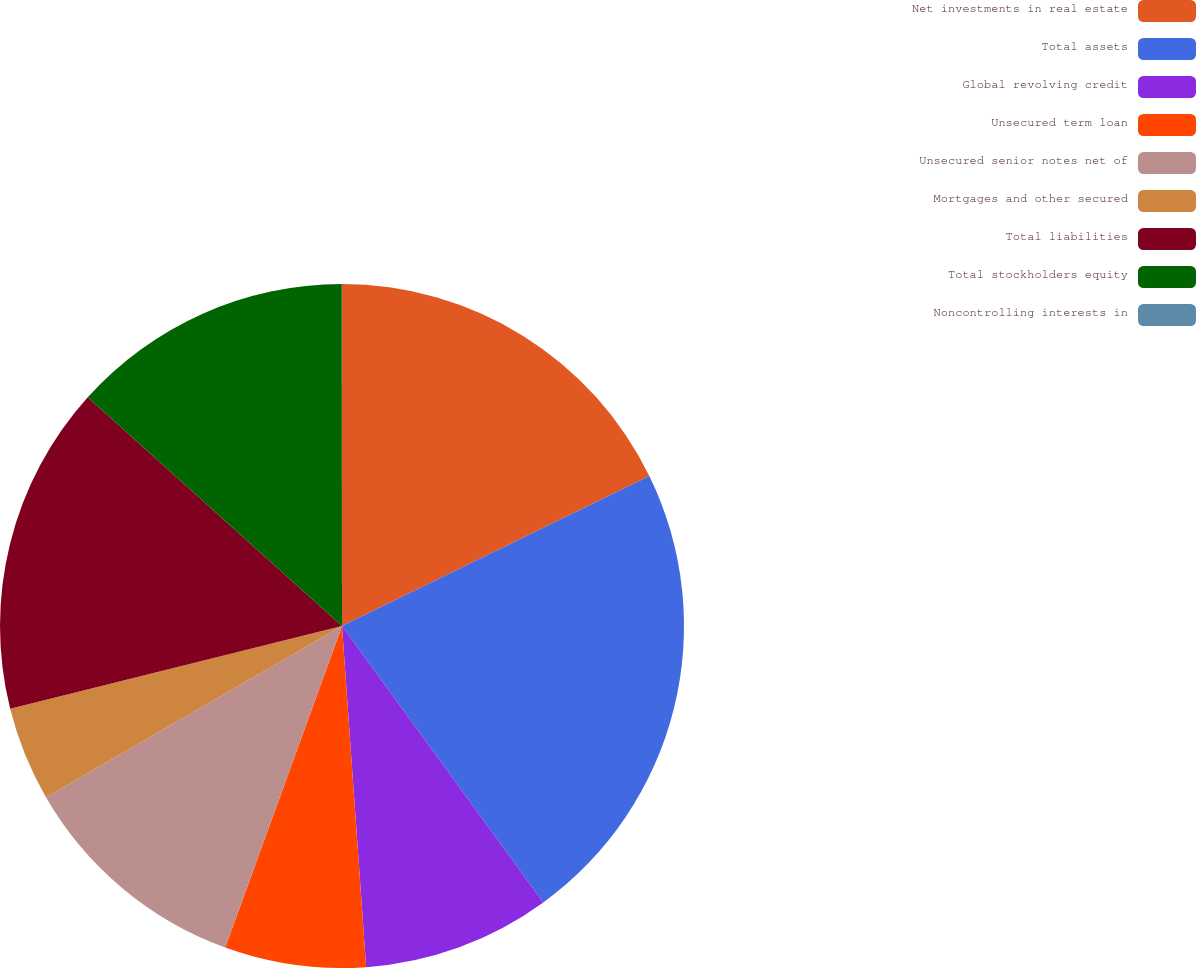<chart> <loc_0><loc_0><loc_500><loc_500><pie_chart><fcel>Net investments in real estate<fcel>Total assets<fcel>Global revolving credit<fcel>Unsecured term loan<fcel>Unsecured senior notes net of<fcel>Mortgages and other secured<fcel>Total liabilities<fcel>Total stockholders equity<fcel>Noncontrolling interests in<nl><fcel>17.77%<fcel>22.21%<fcel>8.89%<fcel>6.67%<fcel>11.11%<fcel>4.45%<fcel>15.55%<fcel>13.33%<fcel>0.01%<nl></chart> 